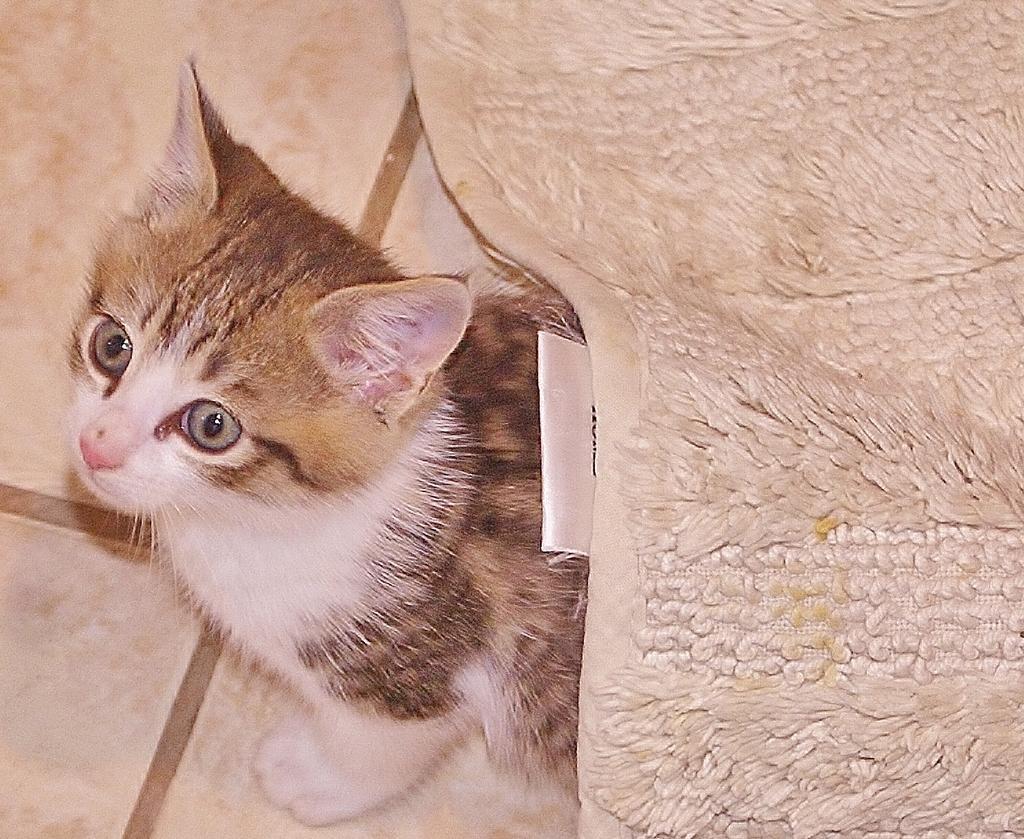In one or two sentences, can you explain what this image depicts? In this image we can see a cat on the floor covered with a blanket. 